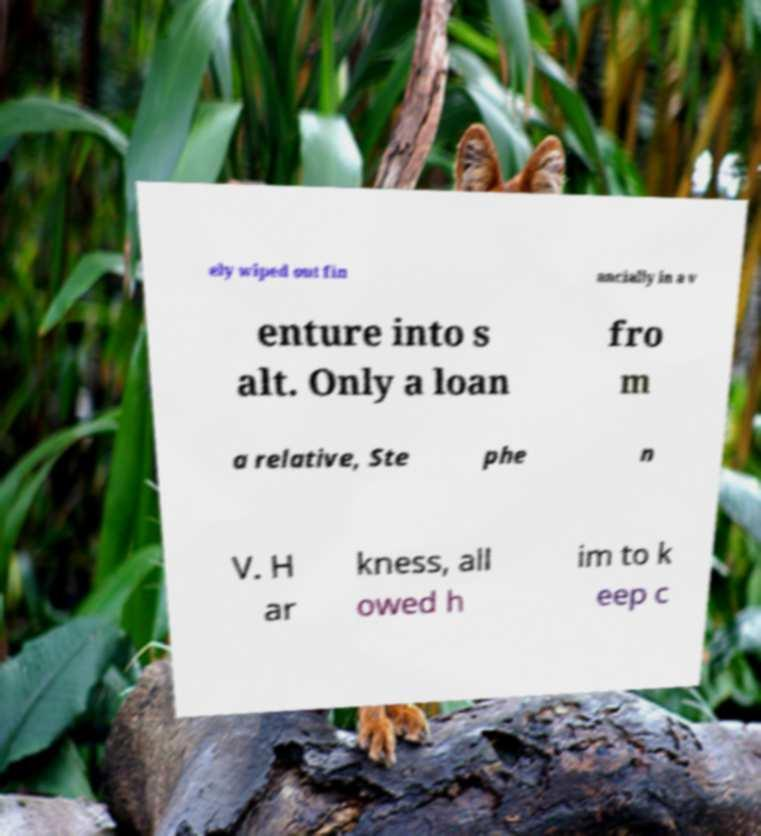For documentation purposes, I need the text within this image transcribed. Could you provide that? ely wiped out fin ancially in a v enture into s alt. Only a loan fro m a relative, Ste phe n V. H ar kness, all owed h im to k eep c 